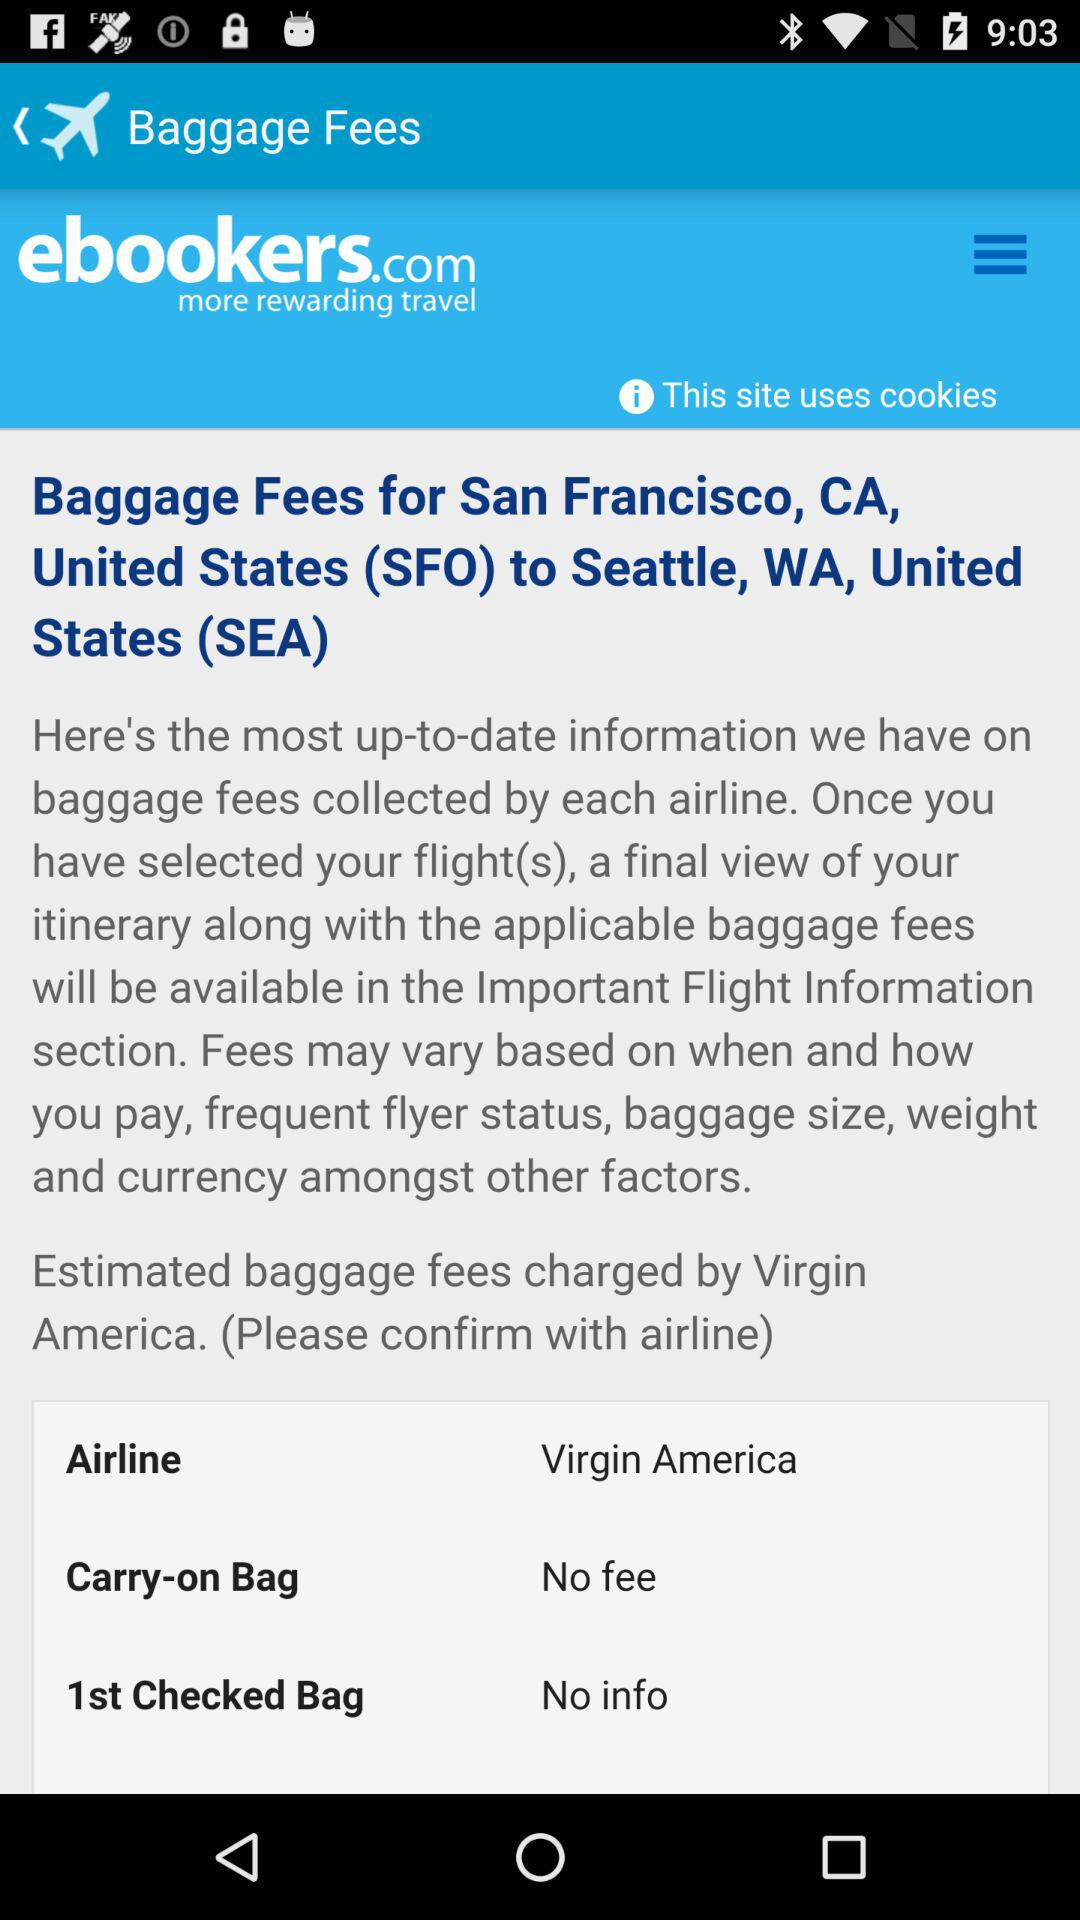What is the carry-on bag fee? There is no fee for the carry-on bag. 